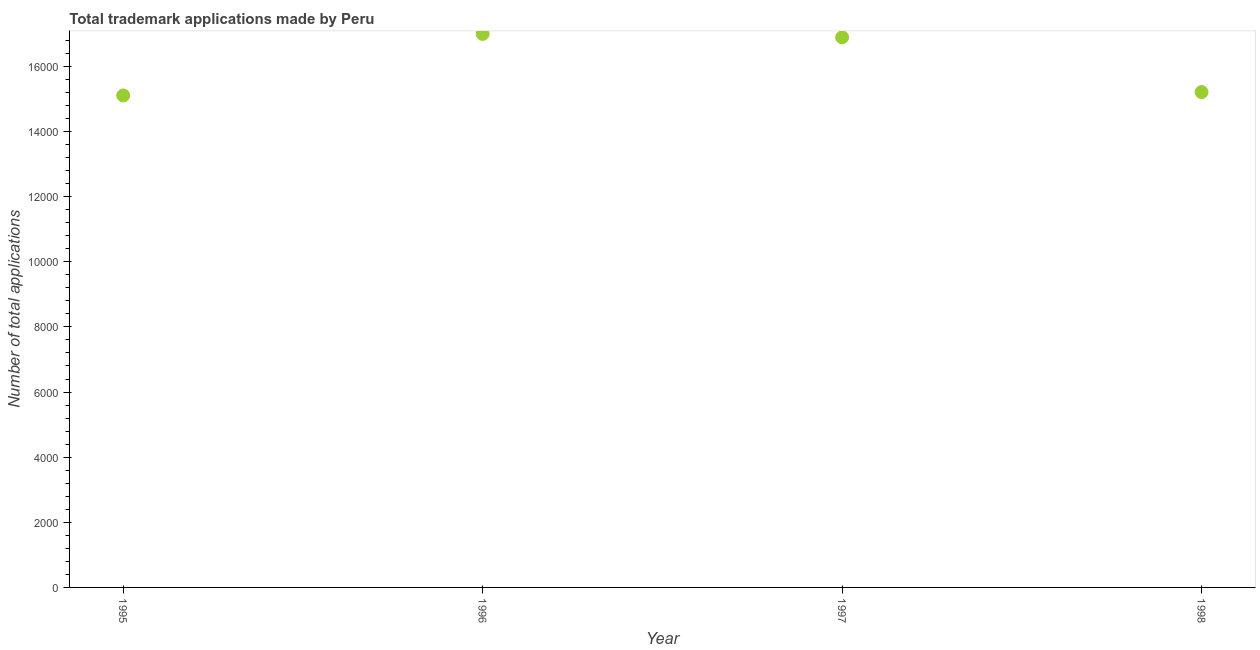What is the number of trademark applications in 1996?
Make the answer very short. 1.70e+04. Across all years, what is the maximum number of trademark applications?
Offer a very short reply. 1.70e+04. Across all years, what is the minimum number of trademark applications?
Keep it short and to the point. 1.51e+04. What is the sum of the number of trademark applications?
Ensure brevity in your answer.  6.42e+04. What is the difference between the number of trademark applications in 1996 and 1997?
Ensure brevity in your answer.  105. What is the average number of trademark applications per year?
Your answer should be very brief. 1.61e+04. What is the median number of trademark applications?
Provide a short and direct response. 1.61e+04. In how many years, is the number of trademark applications greater than 10800 ?
Your response must be concise. 4. What is the ratio of the number of trademark applications in 1997 to that in 1998?
Your answer should be compact. 1.11. What is the difference between the highest and the second highest number of trademark applications?
Provide a short and direct response. 105. What is the difference between the highest and the lowest number of trademark applications?
Ensure brevity in your answer.  1890. Does the number of trademark applications monotonically increase over the years?
Give a very brief answer. No. How many years are there in the graph?
Your response must be concise. 4. What is the difference between two consecutive major ticks on the Y-axis?
Your answer should be very brief. 2000. Are the values on the major ticks of Y-axis written in scientific E-notation?
Ensure brevity in your answer.  No. Does the graph contain grids?
Ensure brevity in your answer.  No. What is the title of the graph?
Keep it short and to the point. Total trademark applications made by Peru. What is the label or title of the Y-axis?
Provide a short and direct response. Number of total applications. What is the Number of total applications in 1995?
Provide a succinct answer. 1.51e+04. What is the Number of total applications in 1996?
Your response must be concise. 1.70e+04. What is the Number of total applications in 1997?
Provide a short and direct response. 1.69e+04. What is the Number of total applications in 1998?
Offer a terse response. 1.52e+04. What is the difference between the Number of total applications in 1995 and 1996?
Your answer should be compact. -1890. What is the difference between the Number of total applications in 1995 and 1997?
Give a very brief answer. -1785. What is the difference between the Number of total applications in 1995 and 1998?
Your answer should be very brief. -104. What is the difference between the Number of total applications in 1996 and 1997?
Give a very brief answer. 105. What is the difference between the Number of total applications in 1996 and 1998?
Provide a succinct answer. 1786. What is the difference between the Number of total applications in 1997 and 1998?
Make the answer very short. 1681. What is the ratio of the Number of total applications in 1995 to that in 1996?
Offer a terse response. 0.89. What is the ratio of the Number of total applications in 1995 to that in 1997?
Your answer should be compact. 0.89. What is the ratio of the Number of total applications in 1996 to that in 1997?
Offer a very short reply. 1.01. What is the ratio of the Number of total applications in 1996 to that in 1998?
Offer a very short reply. 1.12. What is the ratio of the Number of total applications in 1997 to that in 1998?
Your answer should be very brief. 1.11. 